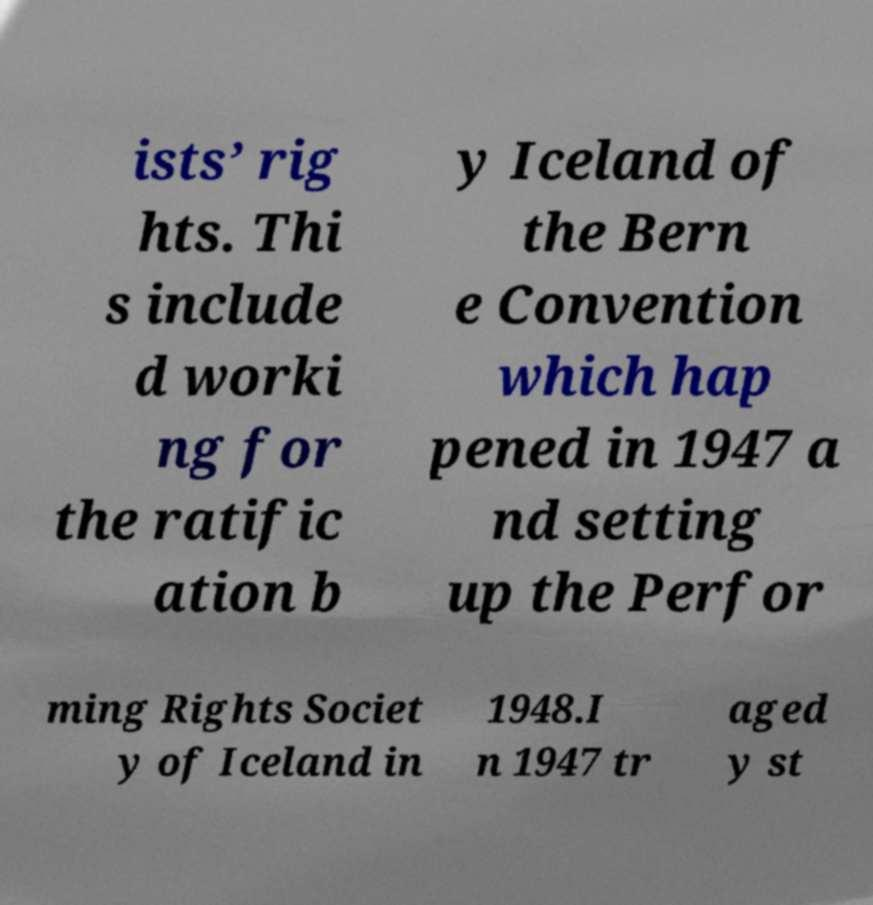Please read and relay the text visible in this image. What does it say? ists’ rig hts. Thi s include d worki ng for the ratific ation b y Iceland of the Bern e Convention which hap pened in 1947 a nd setting up the Perfor ming Rights Societ y of Iceland in 1948.I n 1947 tr aged y st 